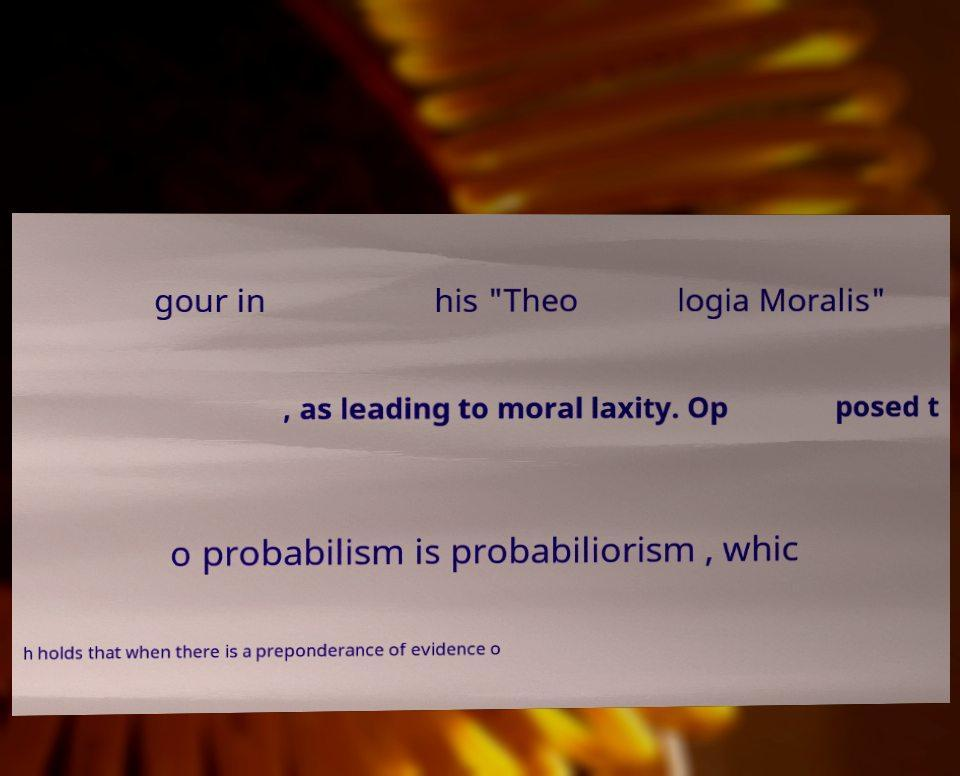Please identify and transcribe the text found in this image. gour in his "Theo logia Moralis" , as leading to moral laxity. Op posed t o probabilism is probabiliorism , whic h holds that when there is a preponderance of evidence o 